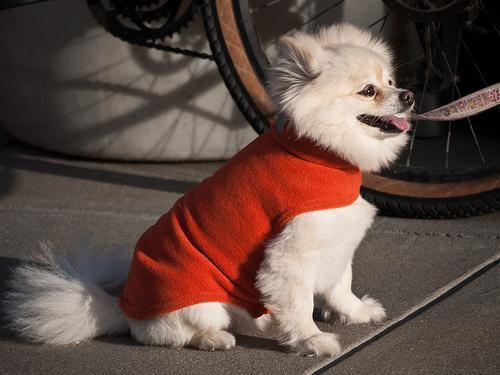How many dogs are in this photo?
Give a very brief answer. 1. How many of the dog's feet are visible?
Give a very brief answer. 3. 